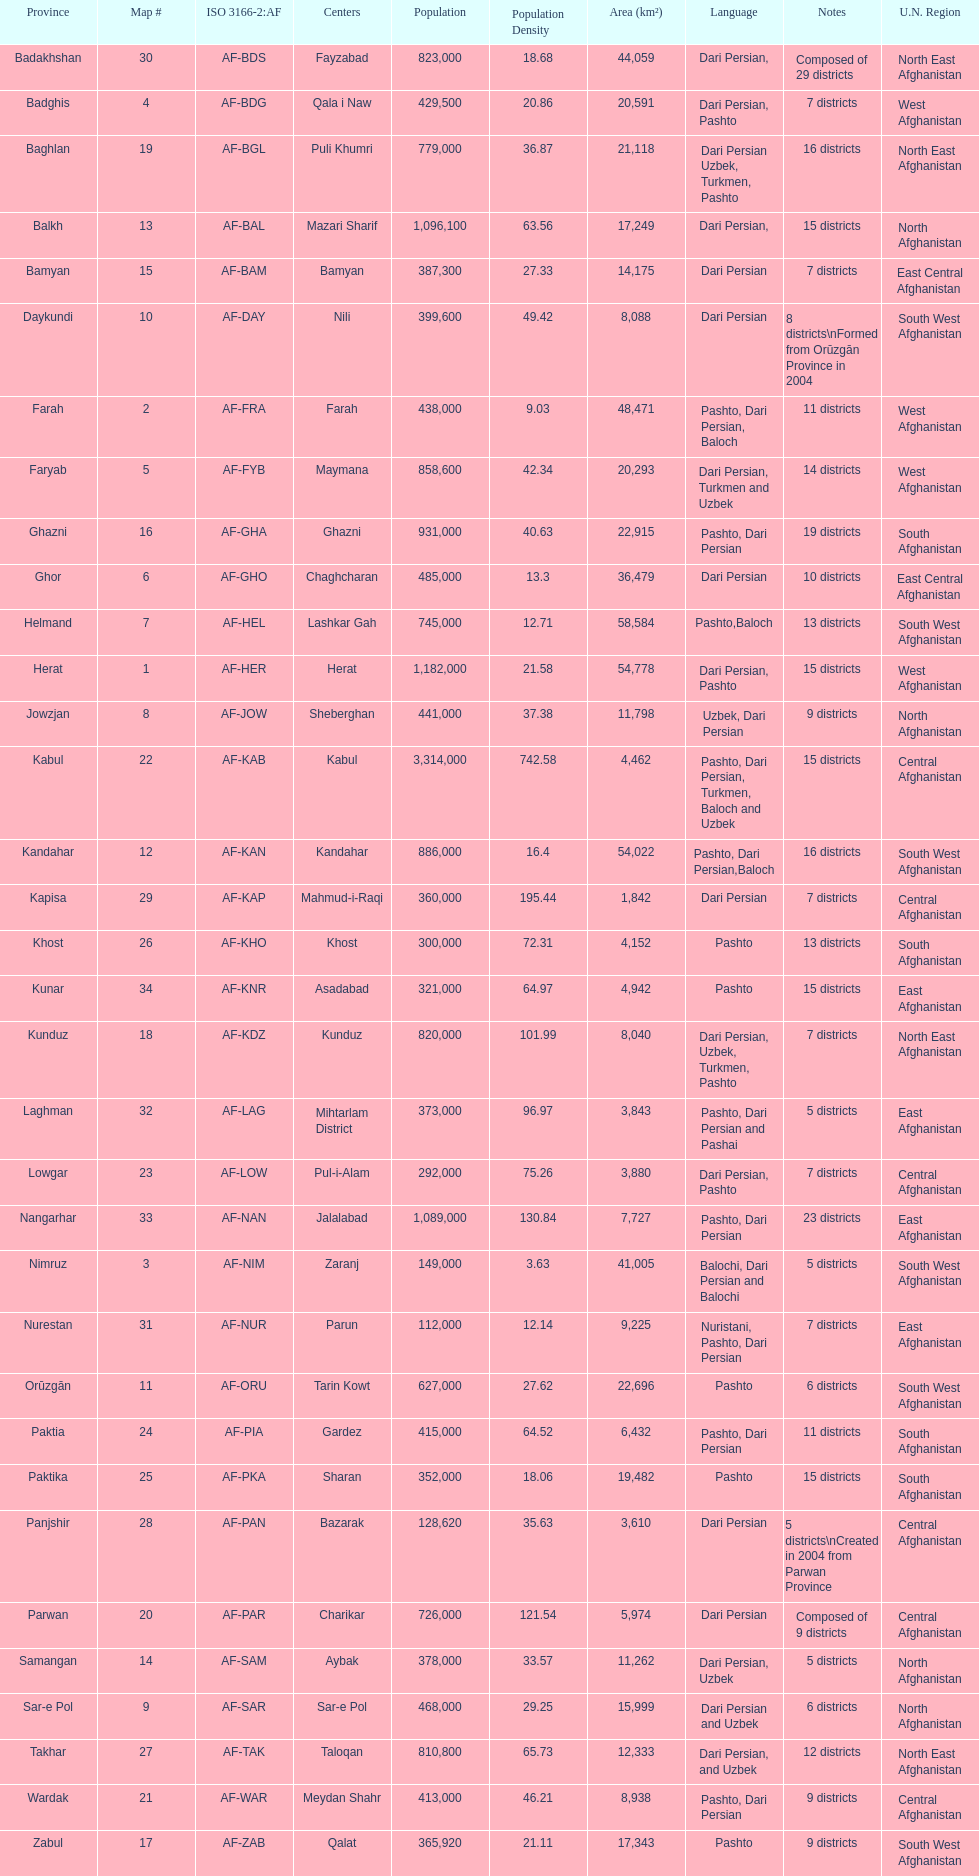With a population of 1,182,000 in herat, can you mention their languages? Dari Persian, Pashto. 